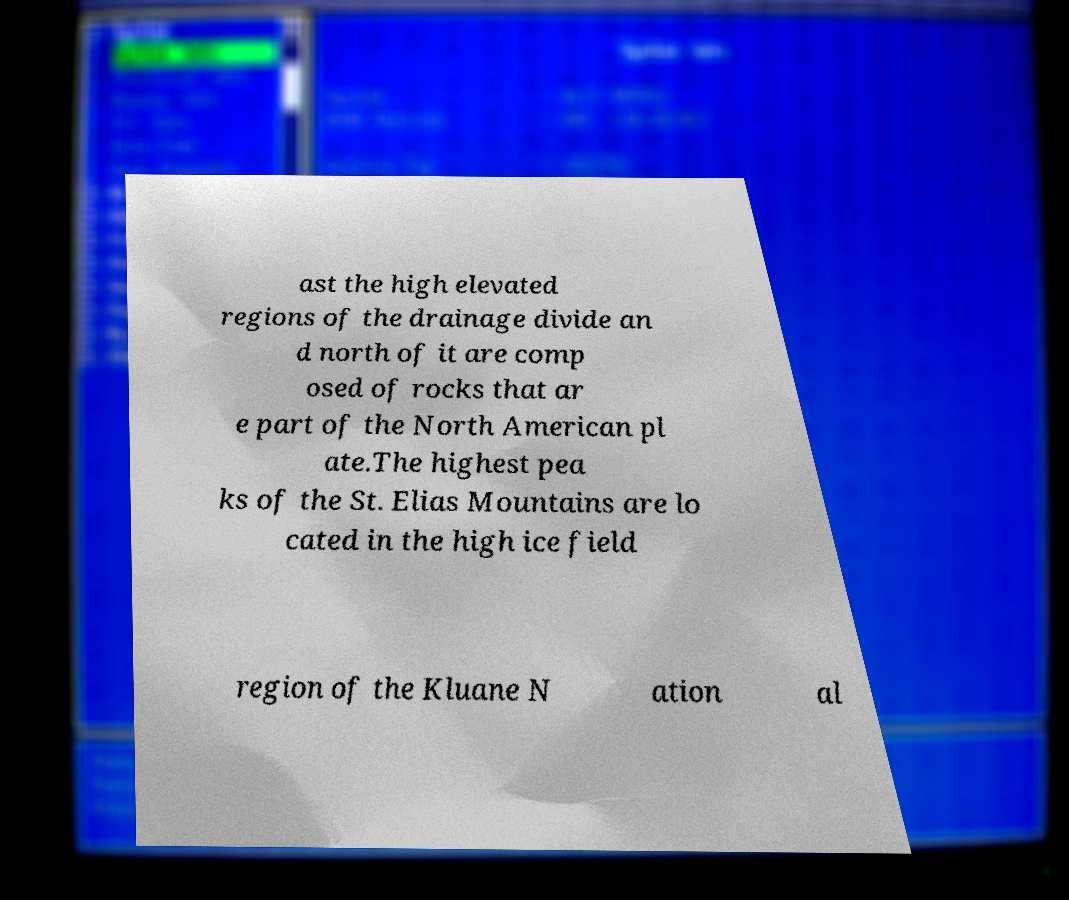Can you accurately transcribe the text from the provided image for me? ast the high elevated regions of the drainage divide an d north of it are comp osed of rocks that ar e part of the North American pl ate.The highest pea ks of the St. Elias Mountains are lo cated in the high ice field region of the Kluane N ation al 